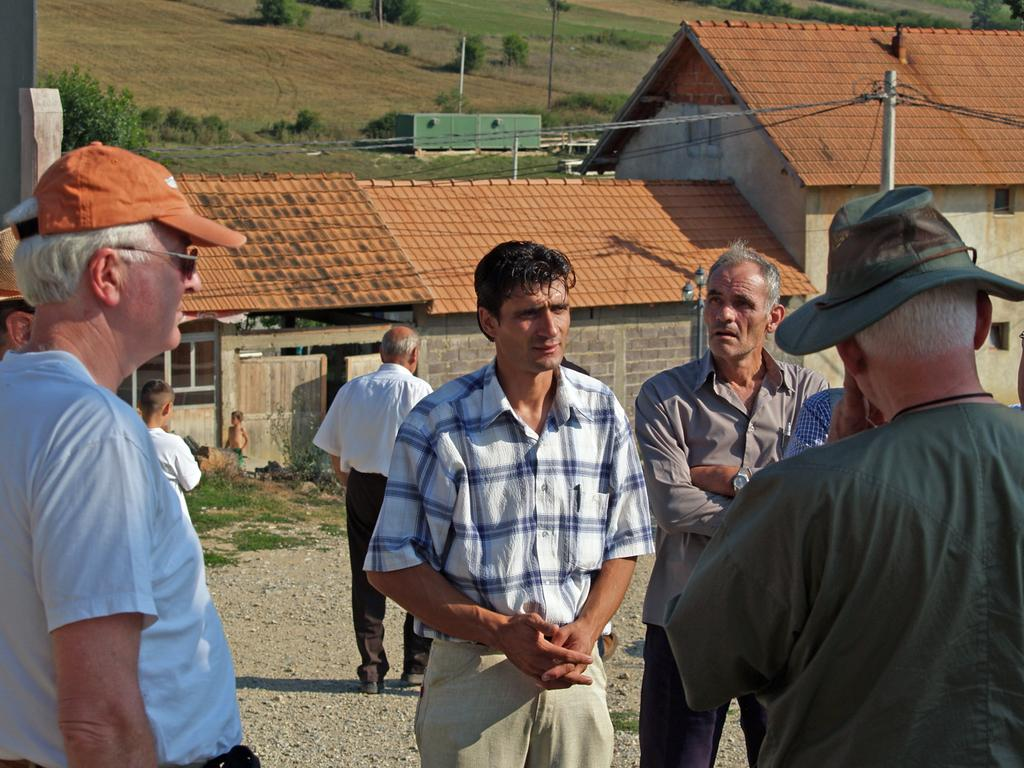What can be seen in the foreground of the image? There are men standing in the foreground of the image. What is visible behind the men? There are buildings visible behind the men. What type of natural elements can be seen in the background of the image? There are trees and plants in the background of the image. What else can be seen in the background of the image? There is empty land visible in the background of the image. What type of drink is being served in the image? There is no drink visible in the image. Can you see a needle in the image? There is no needle present in the image. 